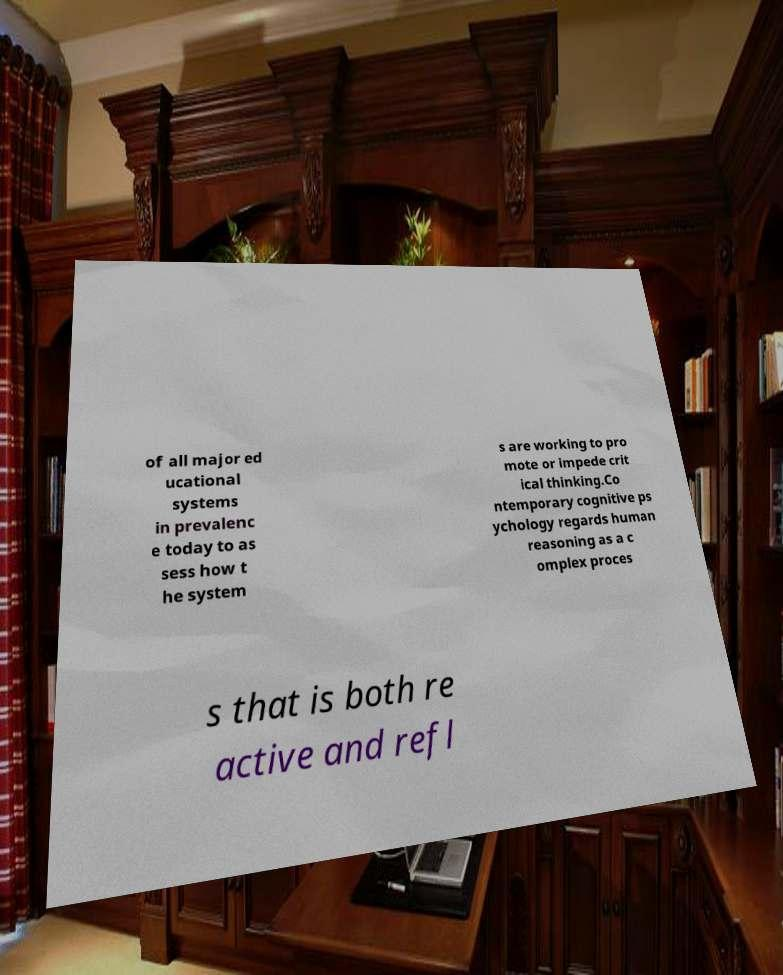Could you extract and type out the text from this image? of all major ed ucational systems in prevalenc e today to as sess how t he system s are working to pro mote or impede crit ical thinking.Co ntemporary cognitive ps ychology regards human reasoning as a c omplex proces s that is both re active and refl 